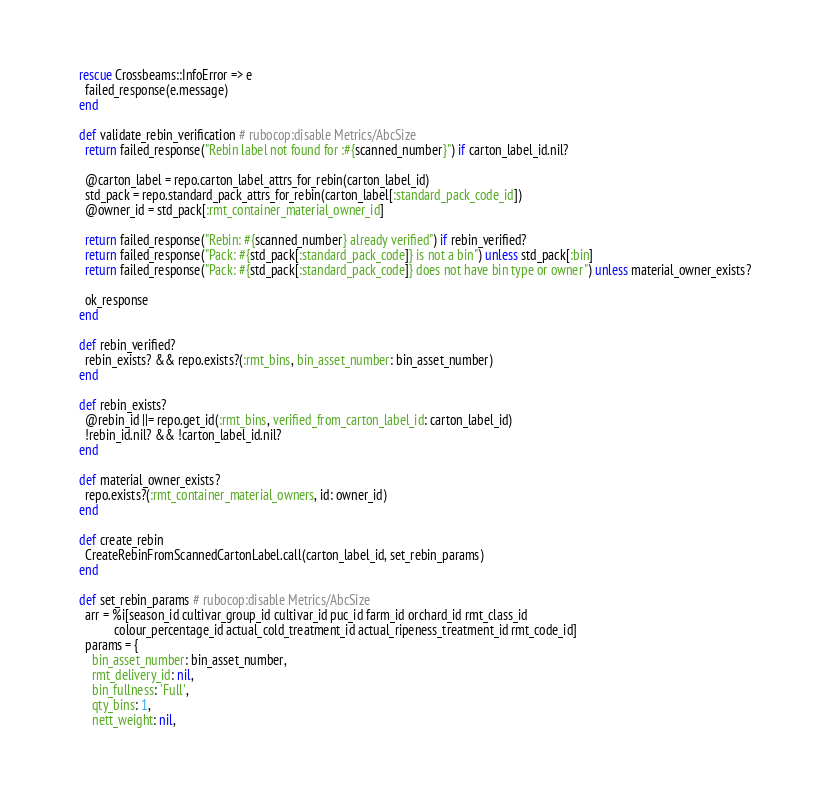Convert code to text. <code><loc_0><loc_0><loc_500><loc_500><_Ruby_>    rescue Crossbeams::InfoError => e
      failed_response(e.message)
    end

    def validate_rebin_verification # rubocop:disable Metrics/AbcSize
      return failed_response("Rebin label not found for :#{scanned_number}") if carton_label_id.nil?

      @carton_label = repo.carton_label_attrs_for_rebin(carton_label_id)
      std_pack = repo.standard_pack_attrs_for_rebin(carton_label[:standard_pack_code_id])
      @owner_id = std_pack[:rmt_container_material_owner_id]

      return failed_response("Rebin: #{scanned_number} already verified") if rebin_verified?
      return failed_response("Pack: #{std_pack[:standard_pack_code]} is not a bin") unless std_pack[:bin]
      return failed_response("Pack: #{std_pack[:standard_pack_code]} does not have bin type or owner") unless material_owner_exists?

      ok_response
    end

    def rebin_verified?
      rebin_exists? && repo.exists?(:rmt_bins, bin_asset_number: bin_asset_number)
    end

    def rebin_exists?
      @rebin_id ||= repo.get_id(:rmt_bins, verified_from_carton_label_id: carton_label_id)
      !rebin_id.nil? && !carton_label_id.nil?
    end

    def material_owner_exists?
      repo.exists?(:rmt_container_material_owners, id: owner_id)
    end

    def create_rebin
      CreateRebinFromScannedCartonLabel.call(carton_label_id, set_rebin_params)
    end

    def set_rebin_params # rubocop:disable Metrics/AbcSize
      arr = %i[season_id cultivar_group_id cultivar_id puc_id farm_id orchard_id rmt_class_id
               colour_percentage_id actual_cold_treatment_id actual_ripeness_treatment_id rmt_code_id]
      params = {
        bin_asset_number: bin_asset_number,
        rmt_delivery_id: nil,
        bin_fullness: 'Full',
        qty_bins: 1,
        nett_weight: nil,</code> 